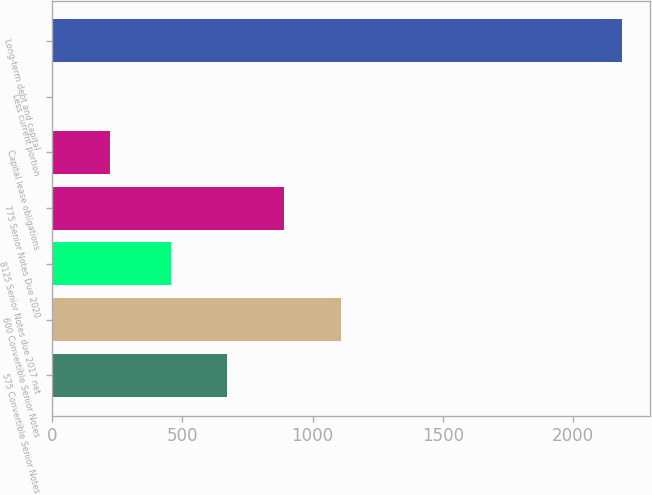Convert chart. <chart><loc_0><loc_0><loc_500><loc_500><bar_chart><fcel>575 Convertible Senior Notes<fcel>600 Convertible Senior Notes<fcel>8125 Senior Notes due 2017 net<fcel>775 Senior Notes Due 2020<fcel>Capital lease obligations<fcel>Less current portion<fcel>Long-term debt and capital<nl><fcel>672.4<fcel>1109.2<fcel>454<fcel>890.8<fcel>222.4<fcel>4<fcel>2188<nl></chart> 